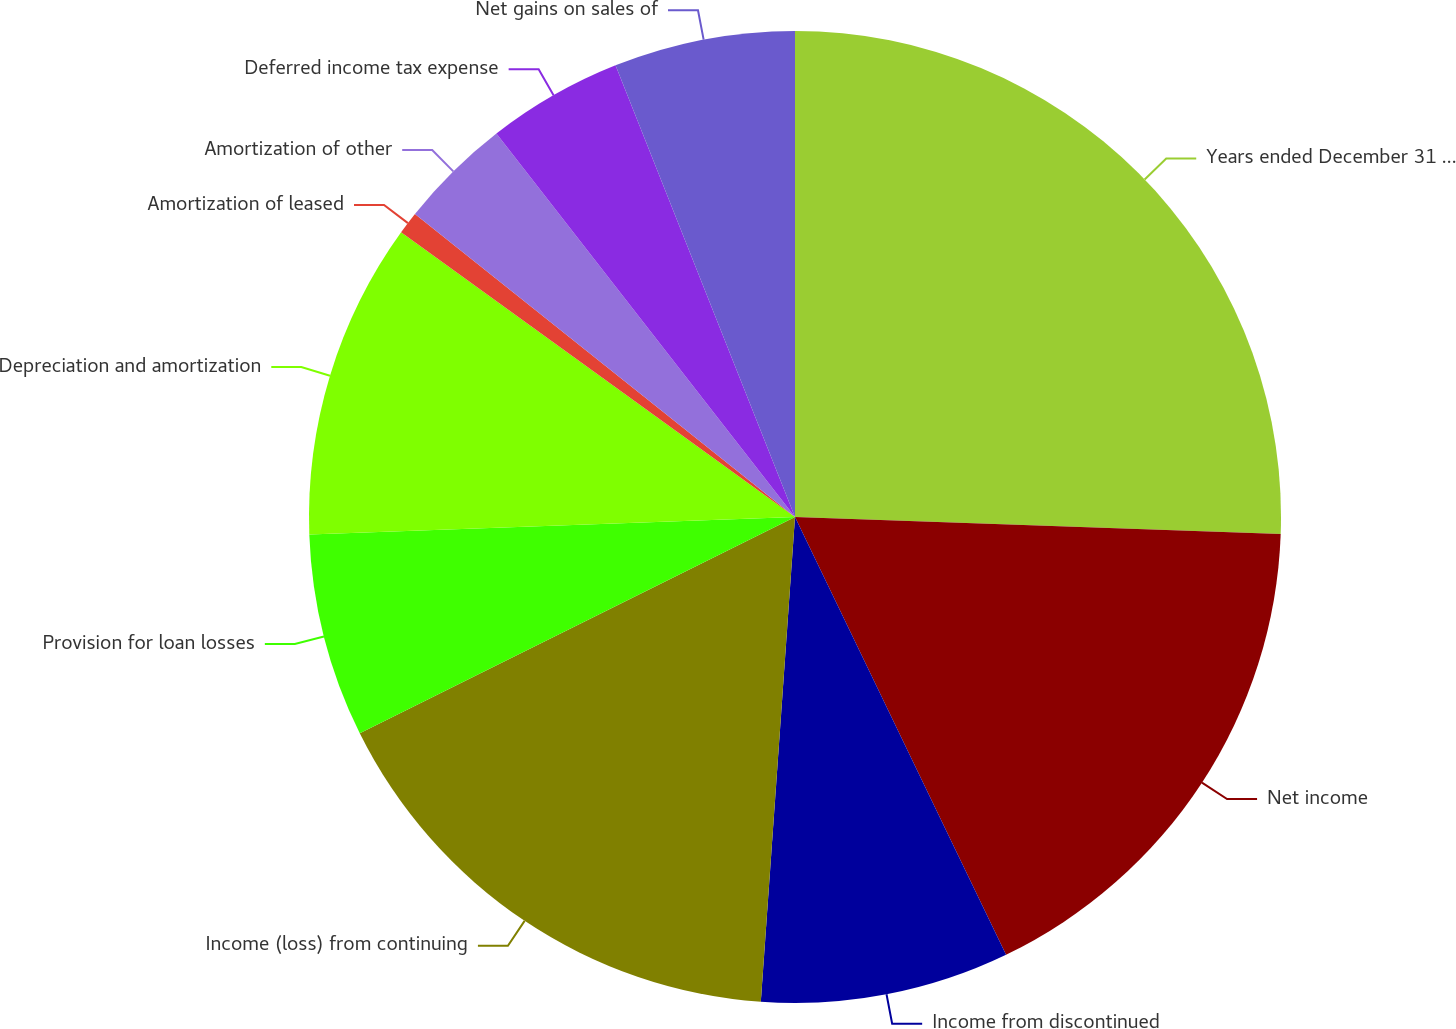Convert chart. <chart><loc_0><loc_0><loc_500><loc_500><pie_chart><fcel>Years ended December 31 (in<fcel>Net income<fcel>Income from discontinued<fcel>Income (loss) from continuing<fcel>Provision for loan losses<fcel>Depreciation and amortization<fcel>Amortization of leased<fcel>Amortization of other<fcel>Deferred income tax expense<fcel>Net gains on sales of<nl><fcel>25.56%<fcel>17.29%<fcel>8.27%<fcel>16.54%<fcel>6.77%<fcel>10.53%<fcel>0.75%<fcel>3.76%<fcel>4.51%<fcel>6.02%<nl></chart> 